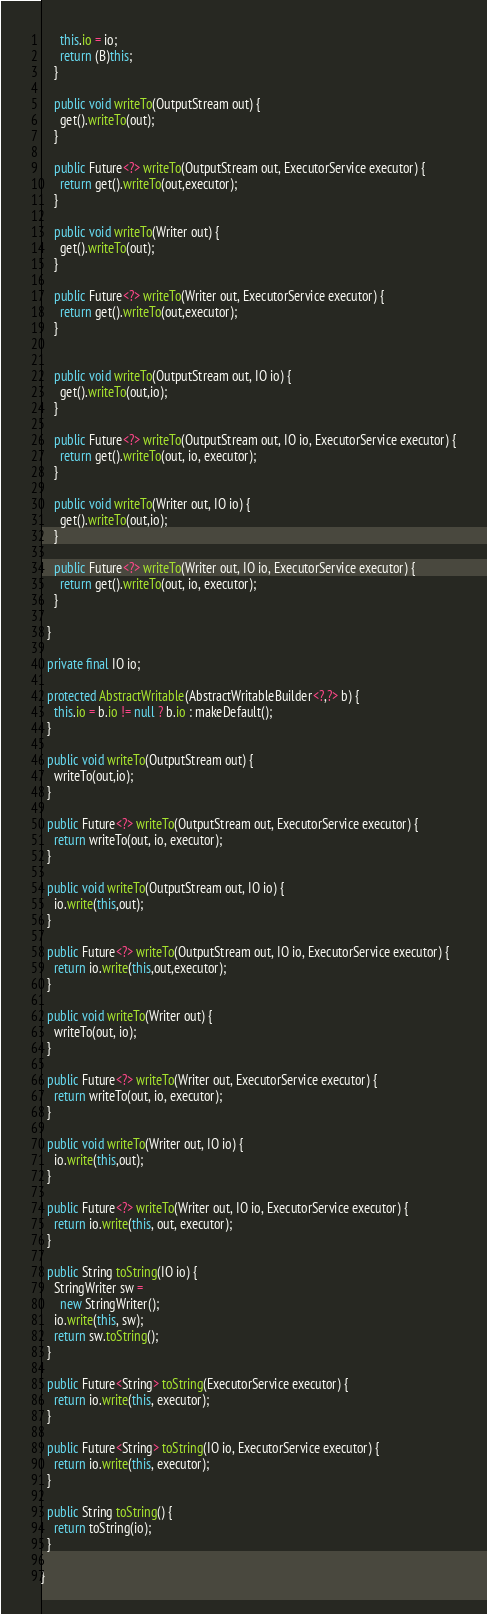<code> <loc_0><loc_0><loc_500><loc_500><_Java_>      this.io = io;
      return (B)this;
    }

    public void writeTo(OutputStream out) {
      get().writeTo(out);
    }
    
    public Future<?> writeTo(OutputStream out, ExecutorService executor) {
      return get().writeTo(out,executor);
    }

    public void writeTo(Writer out) {
      get().writeTo(out);
    }
    
    public Future<?> writeTo(Writer out, ExecutorService executor) {
      return get().writeTo(out,executor);
    }


    public void writeTo(OutputStream out, IO io) {
      get().writeTo(out,io);
    }
    
    public Future<?> writeTo(OutputStream out, IO io, ExecutorService executor) {
      return get().writeTo(out, io, executor);
    }

    public void writeTo(Writer out, IO io) {
      get().writeTo(out,io);
    }
    
    public Future<?> writeTo(Writer out, IO io, ExecutorService executor) {
      return get().writeTo(out, io, executor);
    }
    
  }
  
  private final IO io;

  protected AbstractWritable(AbstractWritableBuilder<?,?> b) {
    this.io = b.io != null ? b.io : makeDefault();
  }
  
  public void writeTo(OutputStream out) {
    writeTo(out,io);
  }
  
  public Future<?> writeTo(OutputStream out, ExecutorService executor) {
    return writeTo(out, io, executor);
  }

  public void writeTo(OutputStream out, IO io) {
    io.write(this,out);
  }
  
  public Future<?> writeTo(OutputStream out, IO io, ExecutorService executor) {
    return io.write(this,out,executor);
  }

  public void writeTo(Writer out) {
    writeTo(out, io);
  }
  
  public Future<?> writeTo(Writer out, ExecutorService executor) {
    return writeTo(out, io, executor);
  }

  public void writeTo(Writer out, IO io) {
    io.write(this,out);
  }
  
  public Future<?> writeTo(Writer out, IO io, ExecutorService executor) {
    return io.write(this, out, executor);
  }
  
  public String toString(IO io) {
    StringWriter sw = 
      new StringWriter();
    io.write(this, sw);
    return sw.toString();    
  }
  
  public Future<String> toString(ExecutorService executor) {
    return io.write(this, executor);
  }
  
  public Future<String> toString(IO io, ExecutorService executor) {
    return io.write(this, executor);
  }
  
  public String toString() {
    return toString(io);
  }

}
</code> 